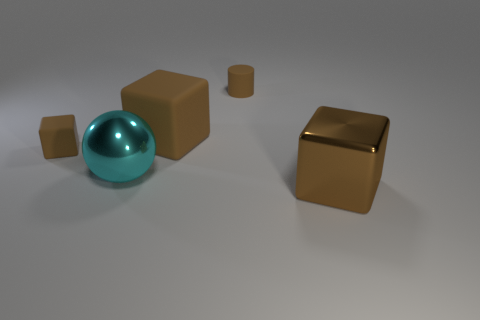How many brown cubes must be subtracted to get 2 brown cubes? 1 Subtract all green spheres. Subtract all cyan cylinders. How many spheres are left? 1 Add 2 purple rubber blocks. How many objects exist? 7 Subtract all cylinders. How many objects are left? 4 Subtract 0 gray spheres. How many objects are left? 5 Subtract all metal blocks. Subtract all large brown rubber cubes. How many objects are left? 3 Add 1 big shiny objects. How many big shiny objects are left? 3 Add 2 large cubes. How many large cubes exist? 4 